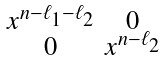<formula> <loc_0><loc_0><loc_500><loc_500>\begin{smallmatrix} x ^ { n - \ell _ { 1 } - \ell _ { 2 } } & 0 \\ 0 & x ^ { n - \ell _ { 2 } } \end{smallmatrix}</formula> 